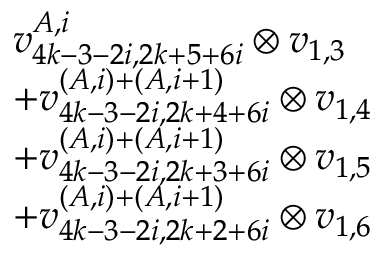Convert formula to latex. <formula><loc_0><loc_0><loc_500><loc_500>\begin{array} { r l } & { v _ { 4 k - 3 - 2 i , 2 k + 5 + 6 i } ^ { A , i } \otimes v _ { 1 , 3 } } \\ & { + v _ { 4 k - 3 - 2 i , 2 k + 4 + 6 i } ^ { ( A , i ) + ( A , i + 1 ) } \otimes v _ { 1 , 4 } } \\ & { + v _ { 4 k - 3 - 2 i , 2 k + 3 + 6 i } ^ { ( A , i ) + ( A , i + 1 ) } \otimes v _ { 1 , 5 } } \\ & { + v _ { 4 k - 3 - 2 i , 2 k + 2 + 6 i } ^ { ( A , i ) + ( A , i + 1 ) } \otimes v _ { 1 , 6 } } \end{array}</formula> 